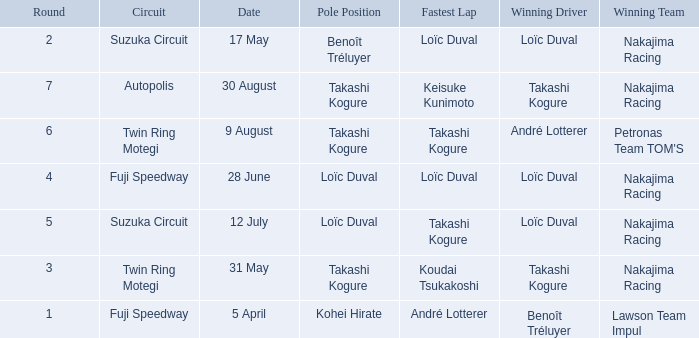Who has the fastest lap where Benoît Tréluyer got the pole position? Loïc Duval. 